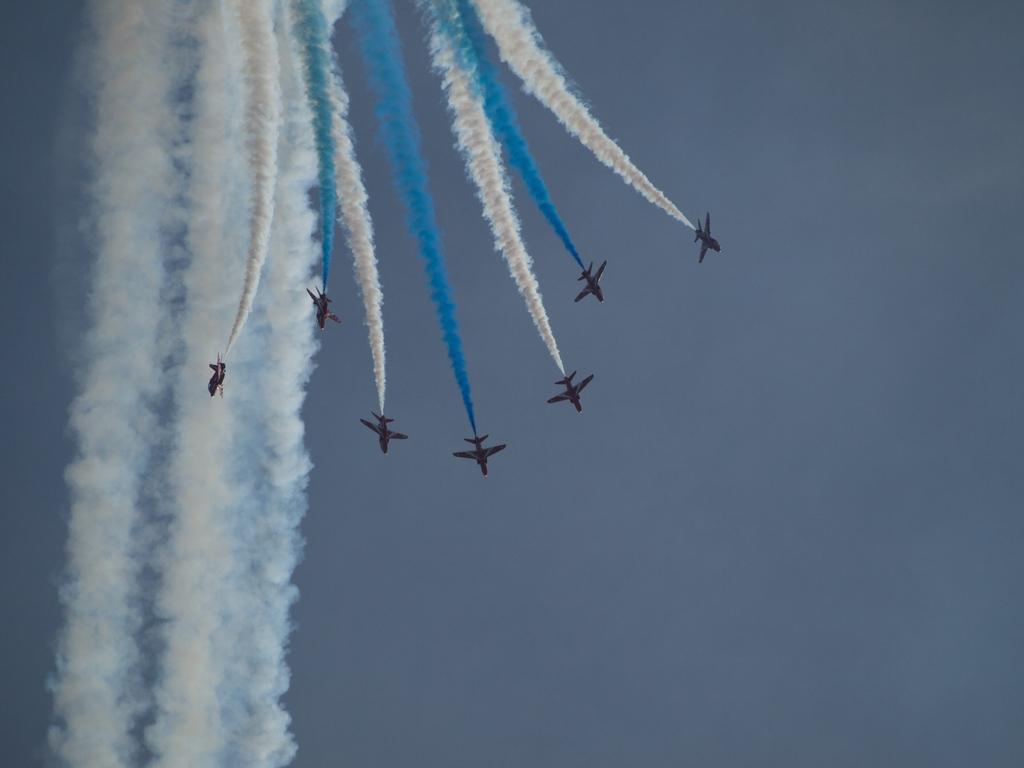Describe this image in one or two sentences. In the center of the image we can see few airplanes. In the background, we can see the sky. And we can see different color smoke. 